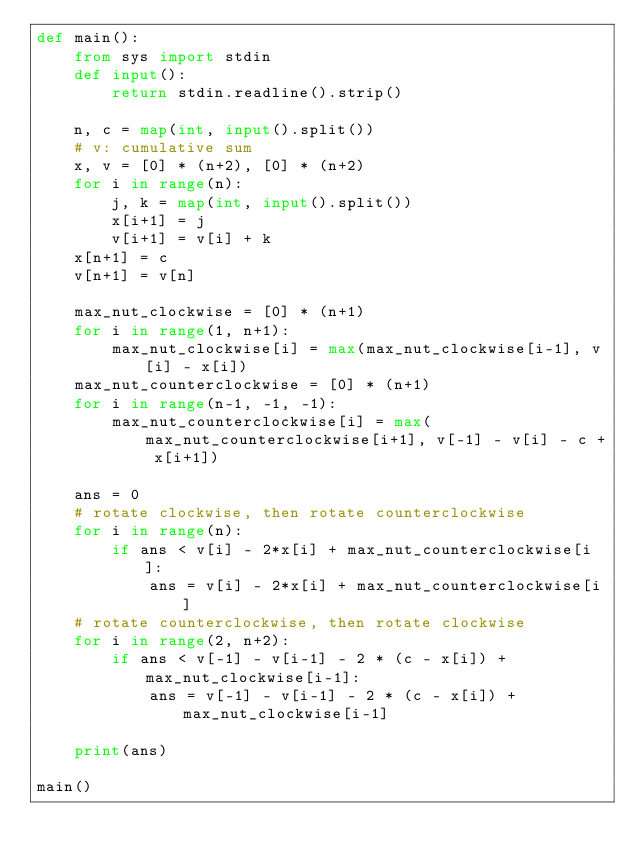Convert code to text. <code><loc_0><loc_0><loc_500><loc_500><_Python_>def main():
    from sys import stdin
    def input():
        return stdin.readline().strip()

    n, c = map(int, input().split())
    # v: cumulative sum
    x, v = [0] * (n+2), [0] * (n+2)
    for i in range(n):
        j, k = map(int, input().split())
        x[i+1] = j
        v[i+1] = v[i] + k
    x[n+1] = c
    v[n+1] = v[n]
    
    max_nut_clockwise = [0] * (n+1)
    for i in range(1, n+1):
        max_nut_clockwise[i] = max(max_nut_clockwise[i-1], v[i] - x[i])
    max_nut_counterclockwise = [0] * (n+1)
    for i in range(n-1, -1, -1):
        max_nut_counterclockwise[i] = max(max_nut_counterclockwise[i+1], v[-1] - v[i] - c + x[i+1])

    ans = 0
    # rotate clockwise, then rotate counterclockwise
    for i in range(n):
        if ans < v[i] - 2*x[i] + max_nut_counterclockwise[i]:
            ans = v[i] - 2*x[i] + max_nut_counterclockwise[i]
    # rotate counterclockwise, then rotate clockwise
    for i in range(2, n+2):
        if ans < v[-1] - v[i-1] - 2 * (c - x[i]) + max_nut_clockwise[i-1]:
            ans = v[-1] - v[i-1] - 2 * (c - x[i]) + max_nut_clockwise[i-1]
    
    print(ans)

main()
</code> 